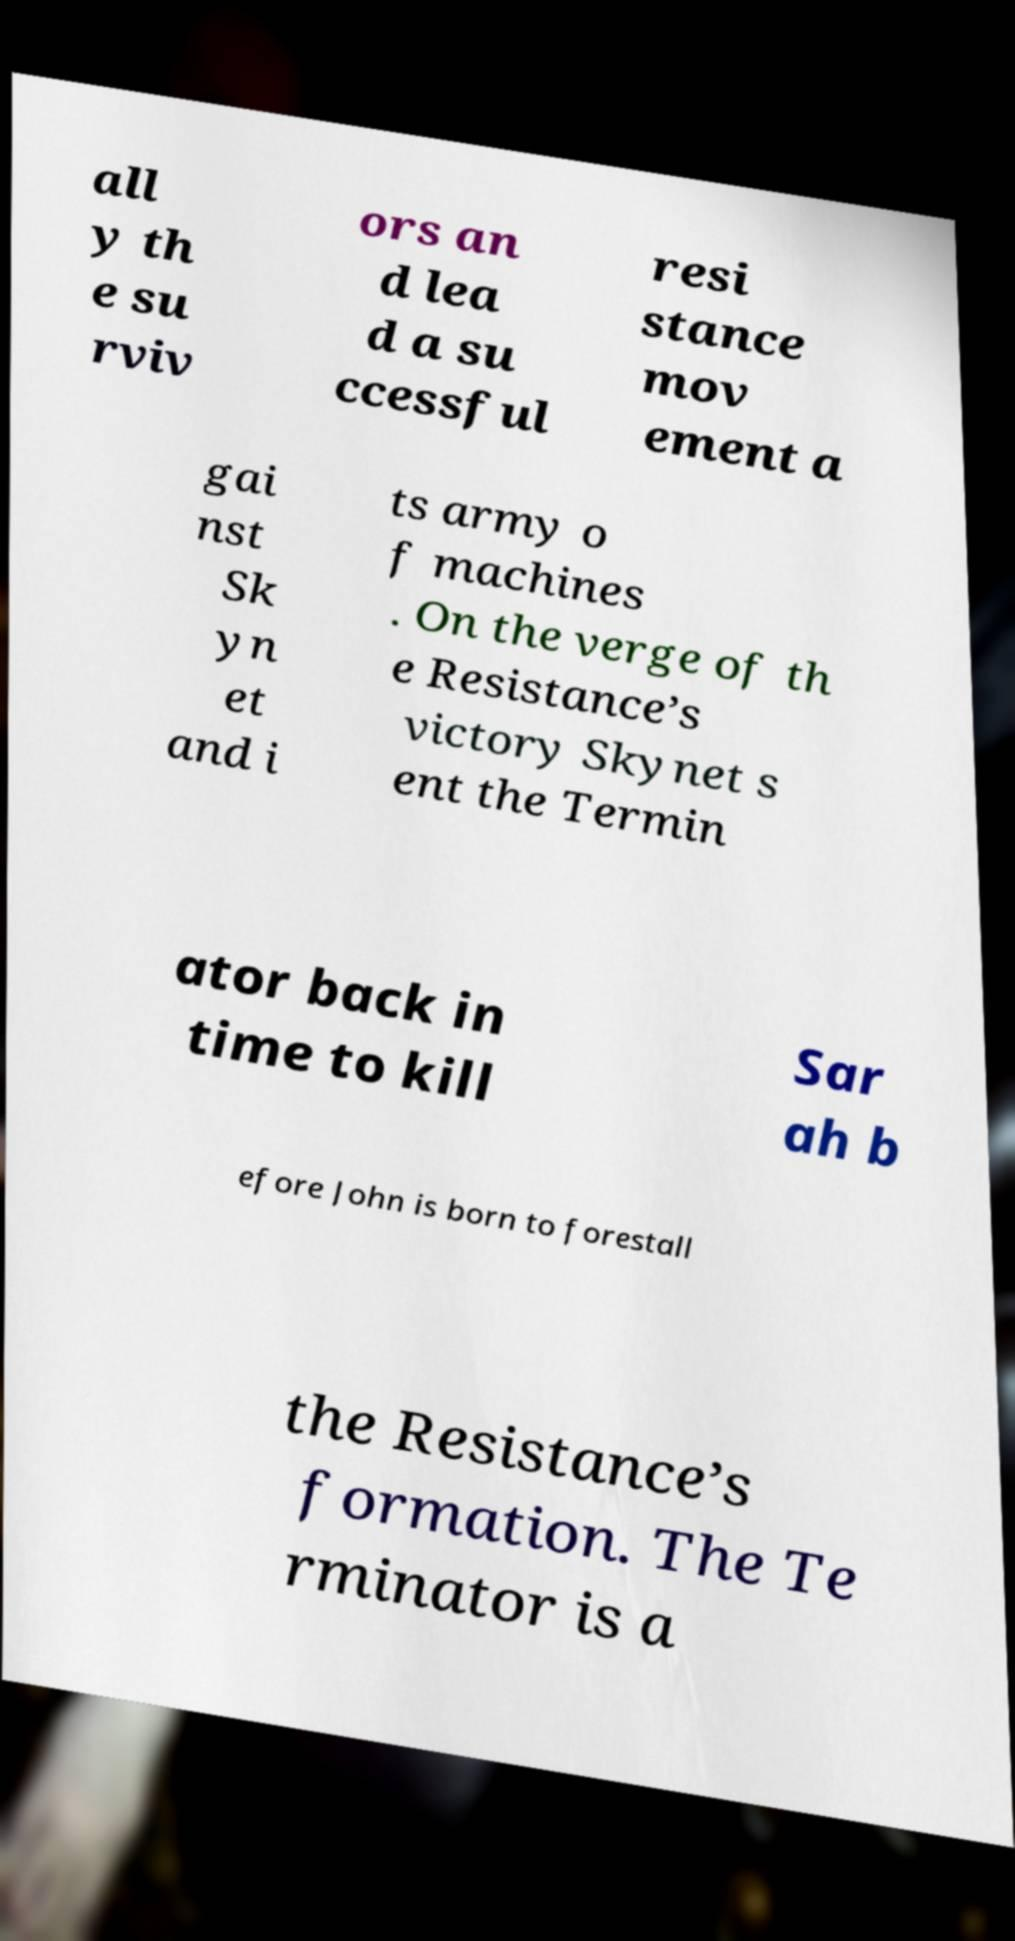Could you assist in decoding the text presented in this image and type it out clearly? all y th e su rviv ors an d lea d a su ccessful resi stance mov ement a gai nst Sk yn et and i ts army o f machines . On the verge of th e Resistance’s victory Skynet s ent the Termin ator back in time to kill Sar ah b efore John is born to forestall the Resistance’s formation. The Te rminator is a 